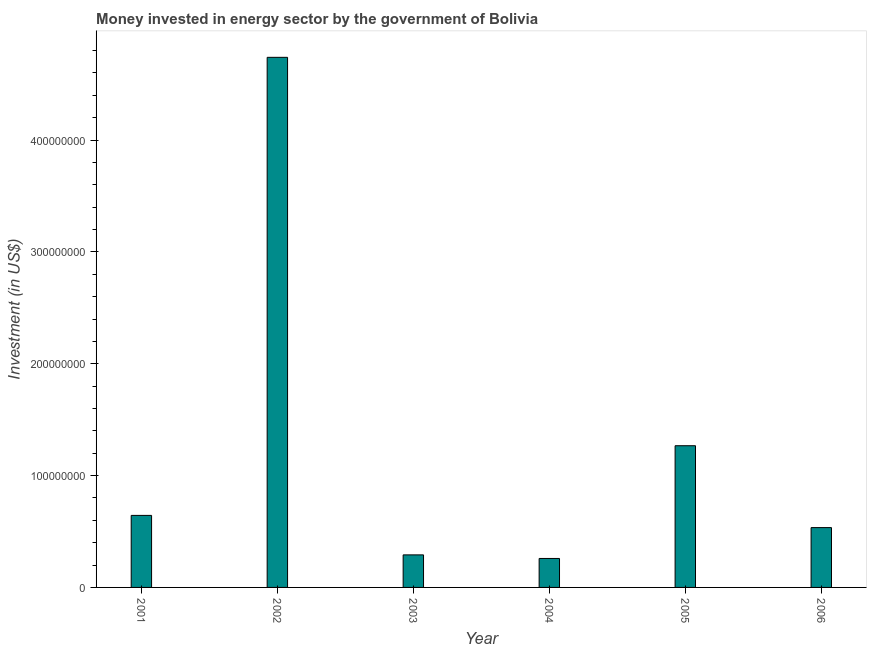Does the graph contain grids?
Ensure brevity in your answer.  No. What is the title of the graph?
Offer a very short reply. Money invested in energy sector by the government of Bolivia. What is the label or title of the Y-axis?
Offer a very short reply. Investment (in US$). What is the investment in energy in 2001?
Give a very brief answer. 6.44e+07. Across all years, what is the maximum investment in energy?
Your response must be concise. 4.74e+08. Across all years, what is the minimum investment in energy?
Keep it short and to the point. 2.59e+07. In which year was the investment in energy maximum?
Ensure brevity in your answer.  2002. In which year was the investment in energy minimum?
Ensure brevity in your answer.  2004. What is the sum of the investment in energy?
Offer a very short reply. 7.74e+08. What is the difference between the investment in energy in 2002 and 2004?
Your response must be concise. 4.48e+08. What is the average investment in energy per year?
Your answer should be very brief. 1.29e+08. What is the median investment in energy?
Give a very brief answer. 5.90e+07. In how many years, is the investment in energy greater than 180000000 US$?
Your answer should be compact. 1. What is the ratio of the investment in energy in 2001 to that in 2006?
Provide a succinct answer. 1.2. Is the investment in energy in 2002 less than that in 2006?
Give a very brief answer. No. Is the difference between the investment in energy in 2002 and 2004 greater than the difference between any two years?
Give a very brief answer. Yes. What is the difference between the highest and the second highest investment in energy?
Ensure brevity in your answer.  3.47e+08. What is the difference between the highest and the lowest investment in energy?
Give a very brief answer. 4.48e+08. How many bars are there?
Provide a succinct answer. 6. How many years are there in the graph?
Your answer should be very brief. 6. Are the values on the major ticks of Y-axis written in scientific E-notation?
Give a very brief answer. No. What is the Investment (in US$) in 2001?
Provide a succinct answer. 6.44e+07. What is the Investment (in US$) in 2002?
Keep it short and to the point. 4.74e+08. What is the Investment (in US$) of 2003?
Ensure brevity in your answer.  2.91e+07. What is the Investment (in US$) of 2004?
Make the answer very short. 2.59e+07. What is the Investment (in US$) in 2005?
Keep it short and to the point. 1.27e+08. What is the Investment (in US$) of 2006?
Keep it short and to the point. 5.35e+07. What is the difference between the Investment (in US$) in 2001 and 2002?
Give a very brief answer. -4.10e+08. What is the difference between the Investment (in US$) in 2001 and 2003?
Your answer should be very brief. 3.53e+07. What is the difference between the Investment (in US$) in 2001 and 2004?
Ensure brevity in your answer.  3.85e+07. What is the difference between the Investment (in US$) in 2001 and 2005?
Provide a short and direct response. -6.23e+07. What is the difference between the Investment (in US$) in 2001 and 2006?
Your answer should be compact. 1.09e+07. What is the difference between the Investment (in US$) in 2002 and 2003?
Make the answer very short. 4.45e+08. What is the difference between the Investment (in US$) in 2002 and 2004?
Make the answer very short. 4.48e+08. What is the difference between the Investment (in US$) in 2002 and 2005?
Give a very brief answer. 3.47e+08. What is the difference between the Investment (in US$) in 2002 and 2006?
Your answer should be very brief. 4.20e+08. What is the difference between the Investment (in US$) in 2003 and 2004?
Ensure brevity in your answer.  3.20e+06. What is the difference between the Investment (in US$) in 2003 and 2005?
Make the answer very short. -9.76e+07. What is the difference between the Investment (in US$) in 2003 and 2006?
Your response must be concise. -2.44e+07. What is the difference between the Investment (in US$) in 2004 and 2005?
Your response must be concise. -1.01e+08. What is the difference between the Investment (in US$) in 2004 and 2006?
Your response must be concise. -2.76e+07. What is the difference between the Investment (in US$) in 2005 and 2006?
Make the answer very short. 7.32e+07. What is the ratio of the Investment (in US$) in 2001 to that in 2002?
Your answer should be compact. 0.14. What is the ratio of the Investment (in US$) in 2001 to that in 2003?
Provide a short and direct response. 2.21. What is the ratio of the Investment (in US$) in 2001 to that in 2004?
Give a very brief answer. 2.49. What is the ratio of the Investment (in US$) in 2001 to that in 2005?
Ensure brevity in your answer.  0.51. What is the ratio of the Investment (in US$) in 2001 to that in 2006?
Ensure brevity in your answer.  1.2. What is the ratio of the Investment (in US$) in 2002 to that in 2003?
Offer a very short reply. 16.29. What is the ratio of the Investment (in US$) in 2002 to that in 2004?
Make the answer very short. 18.3. What is the ratio of the Investment (in US$) in 2002 to that in 2005?
Your answer should be compact. 3.74. What is the ratio of the Investment (in US$) in 2002 to that in 2006?
Give a very brief answer. 8.86. What is the ratio of the Investment (in US$) in 2003 to that in 2004?
Offer a very short reply. 1.12. What is the ratio of the Investment (in US$) in 2003 to that in 2005?
Offer a terse response. 0.23. What is the ratio of the Investment (in US$) in 2003 to that in 2006?
Provide a short and direct response. 0.54. What is the ratio of the Investment (in US$) in 2004 to that in 2005?
Offer a terse response. 0.2. What is the ratio of the Investment (in US$) in 2004 to that in 2006?
Offer a very short reply. 0.48. What is the ratio of the Investment (in US$) in 2005 to that in 2006?
Make the answer very short. 2.37. 